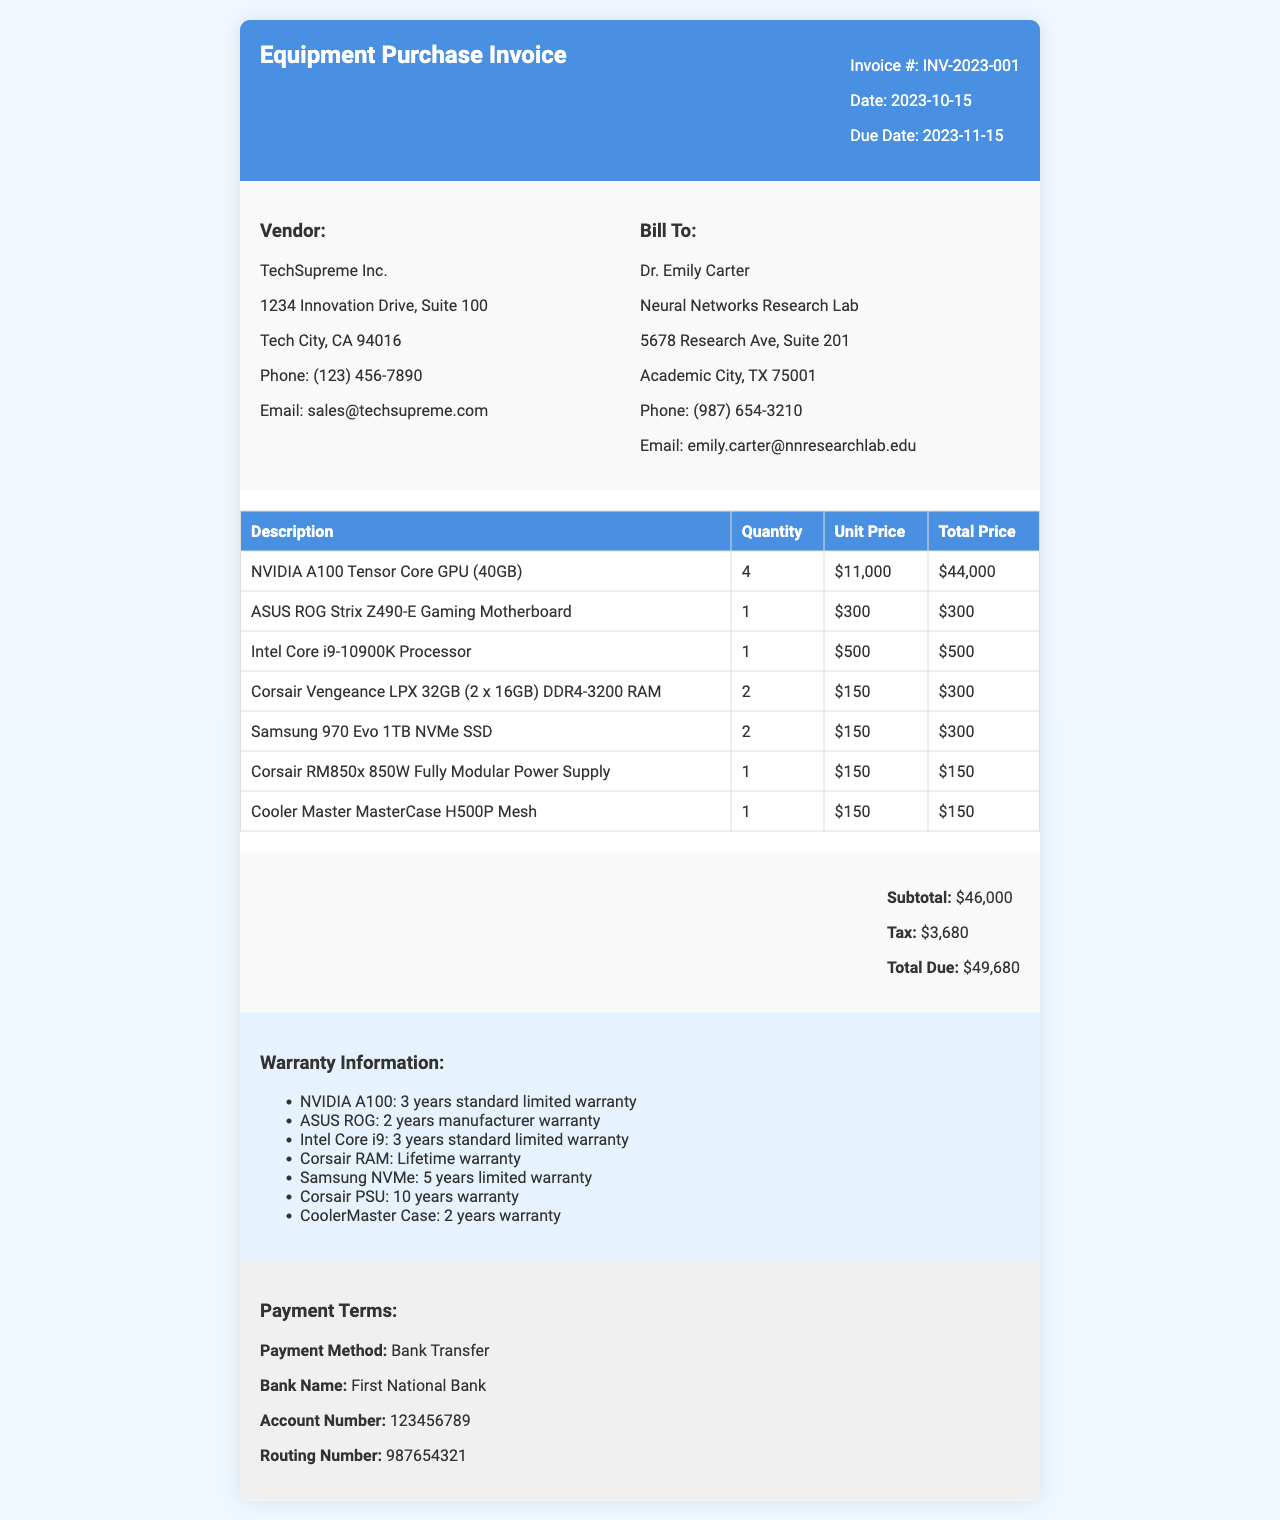What is the invoice number? The invoice number is specified in the document and is listed as INV-2023-001.
Answer: INV-2023-001 Who is the vendor? The vendor's name is provided in the document and is listed as TechSupreme Inc.
Answer: TechSupreme Inc What is the total due amount? The total due amount is calculated by summing the subtotal and tax, which is $46,000 + $3,680.
Answer: $49,680 How many NVIDIA A100 GPUs are purchased? The quantity of NVIDIA A100 GPUs purchased is clearly stated in the invoice as 4.
Answer: 4 What is the warranty period for the Samsung NVMe SSD? The warranty information for the Samsung NVMe SSD is listed in the document as 5 years limited warranty.
Answer: 5 years limited warranty What payment method is specified? The payment method is mentioned under the payment terms section as Bank Transfer.
Answer: Bank Transfer What is the subtotal amount before tax? The subtotal amount is indicated directly in the document as $46,000.
Answer: $46,000 What is the quantity of ASUS ROG Strix motherboards purchased? The quantity for ASUS ROG Strix motherboards is provided in the invoice as 1.
Answer: 1 What is the due date for the invoice payment? The due date for the invoice payment is specified in the document as 2023-11-15.
Answer: 2023-11-15 